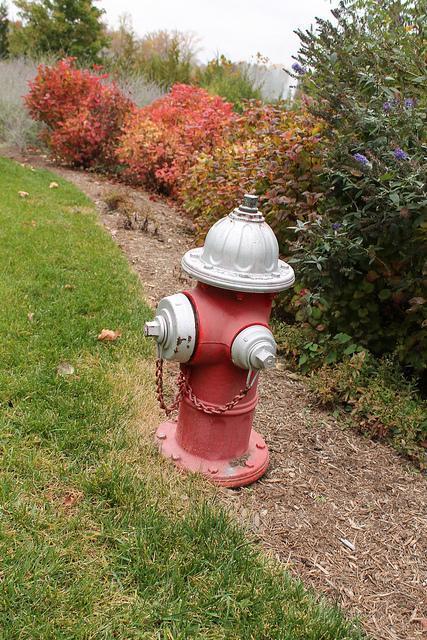How many people should be dining with the man?
Give a very brief answer. 0. 